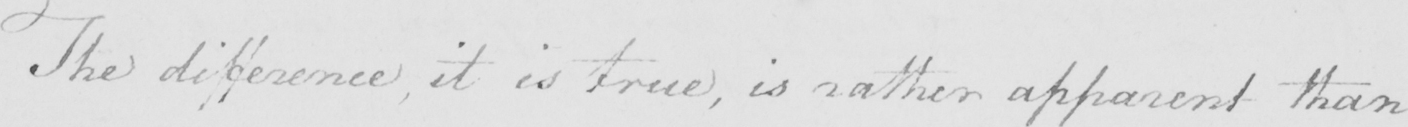Transcribe the text shown in this historical manuscript line. The difference , it is true , is rather apparent than 